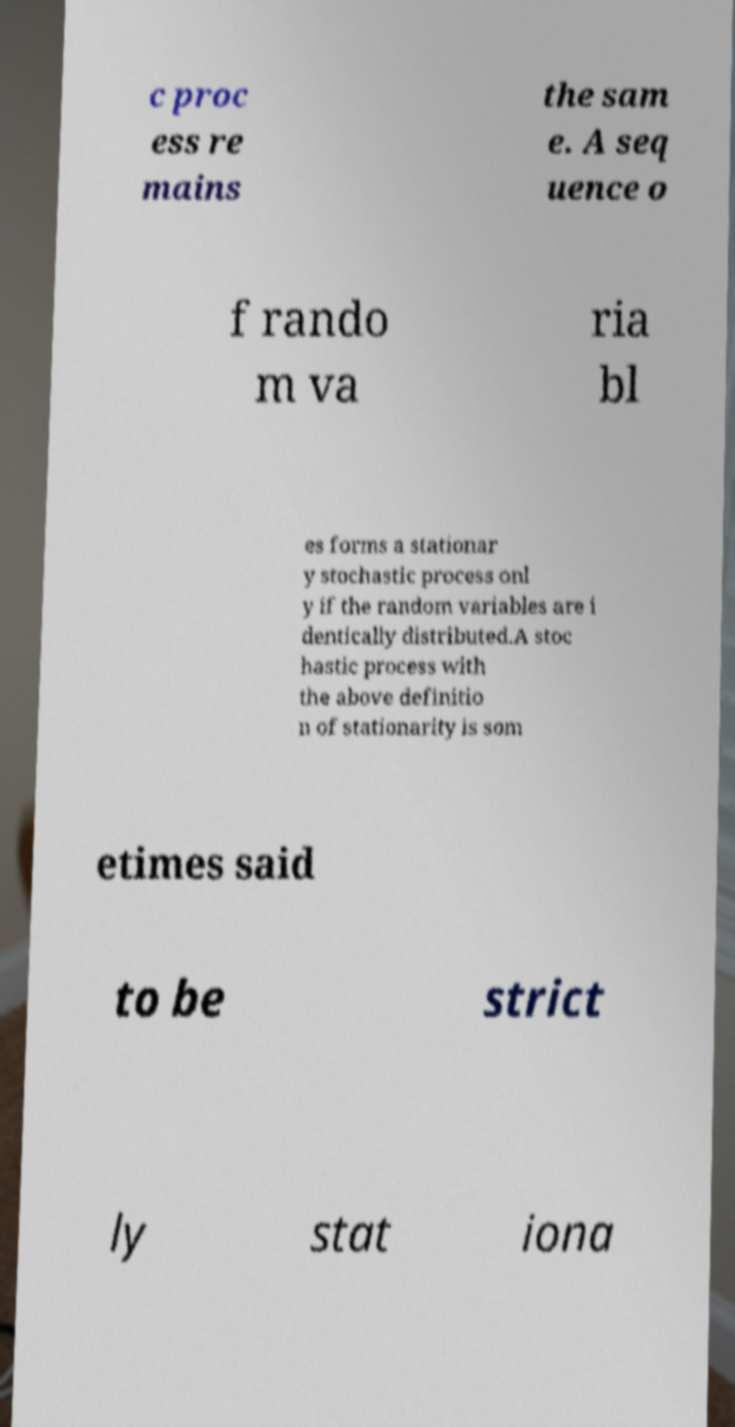Please read and relay the text visible in this image. What does it say? c proc ess re mains the sam e. A seq uence o f rando m va ria bl es forms a stationar y stochastic process onl y if the random variables are i dentically distributed.A stoc hastic process with the above definitio n of stationarity is som etimes said to be strict ly stat iona 